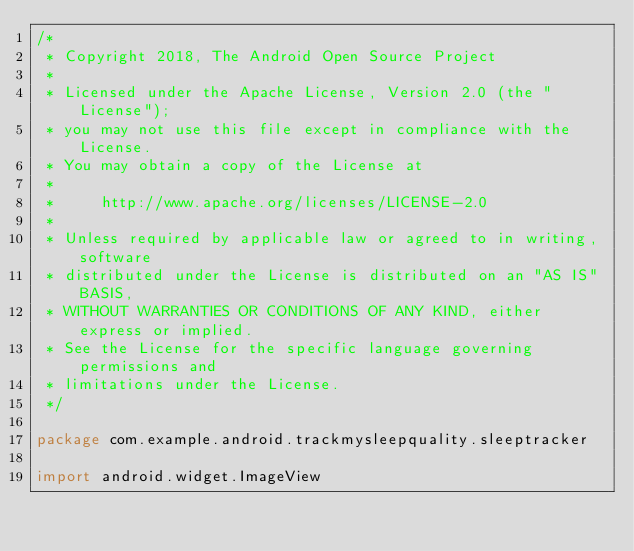<code> <loc_0><loc_0><loc_500><loc_500><_Kotlin_>/*
 * Copyright 2018, The Android Open Source Project
 *
 * Licensed under the Apache License, Version 2.0 (the "License");
 * you may not use this file except in compliance with the License.
 * You may obtain a copy of the License at
 *
 *     http://www.apache.org/licenses/LICENSE-2.0
 *
 * Unless required by applicable law or agreed to in writing, software
 * distributed under the License is distributed on an "AS IS" BASIS,
 * WITHOUT WARRANTIES OR CONDITIONS OF ANY KIND, either express or implied.
 * See the License for the specific language governing permissions and
 * limitations under the License.
 */

package com.example.android.trackmysleepquality.sleeptracker

import android.widget.ImageView</code> 